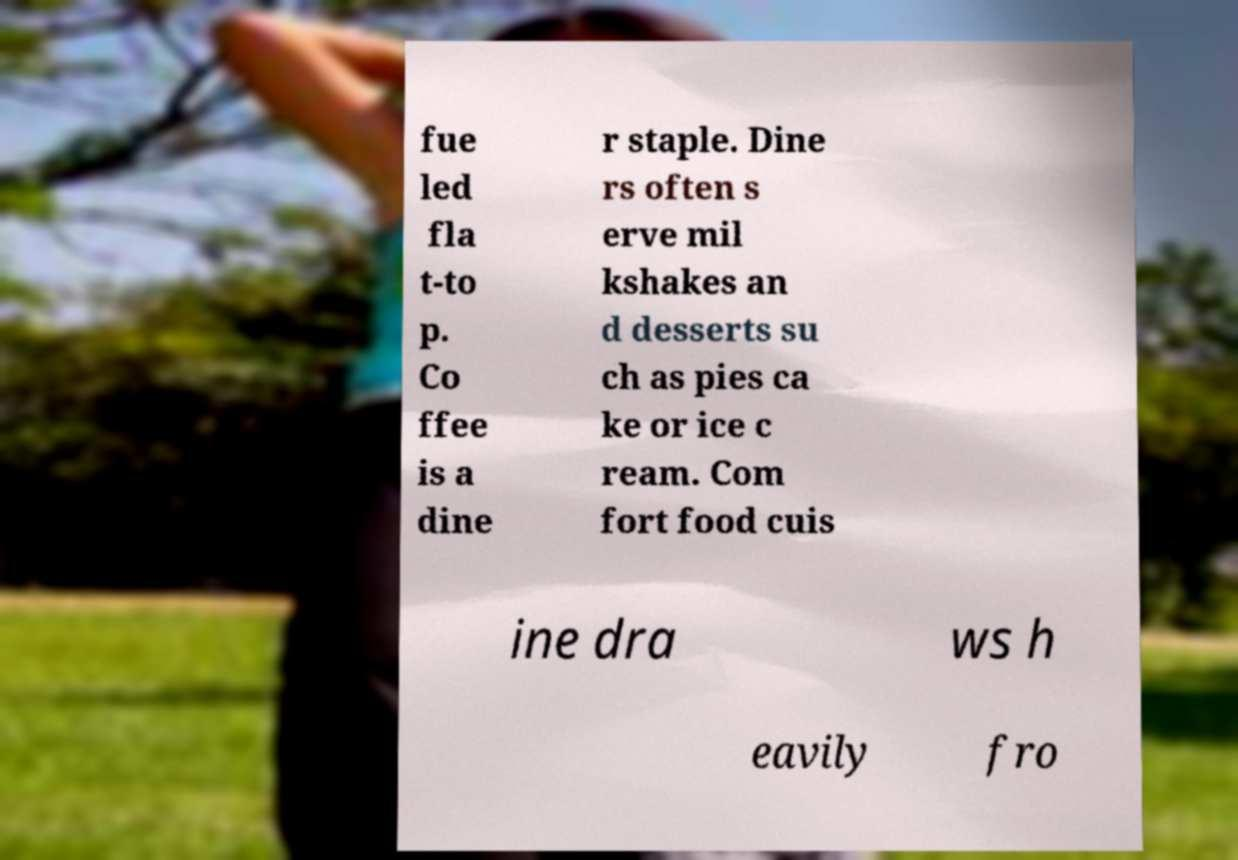Could you assist in decoding the text presented in this image and type it out clearly? fue led fla t-to p. Co ffee is a dine r staple. Dine rs often s erve mil kshakes an d desserts su ch as pies ca ke or ice c ream. Com fort food cuis ine dra ws h eavily fro 